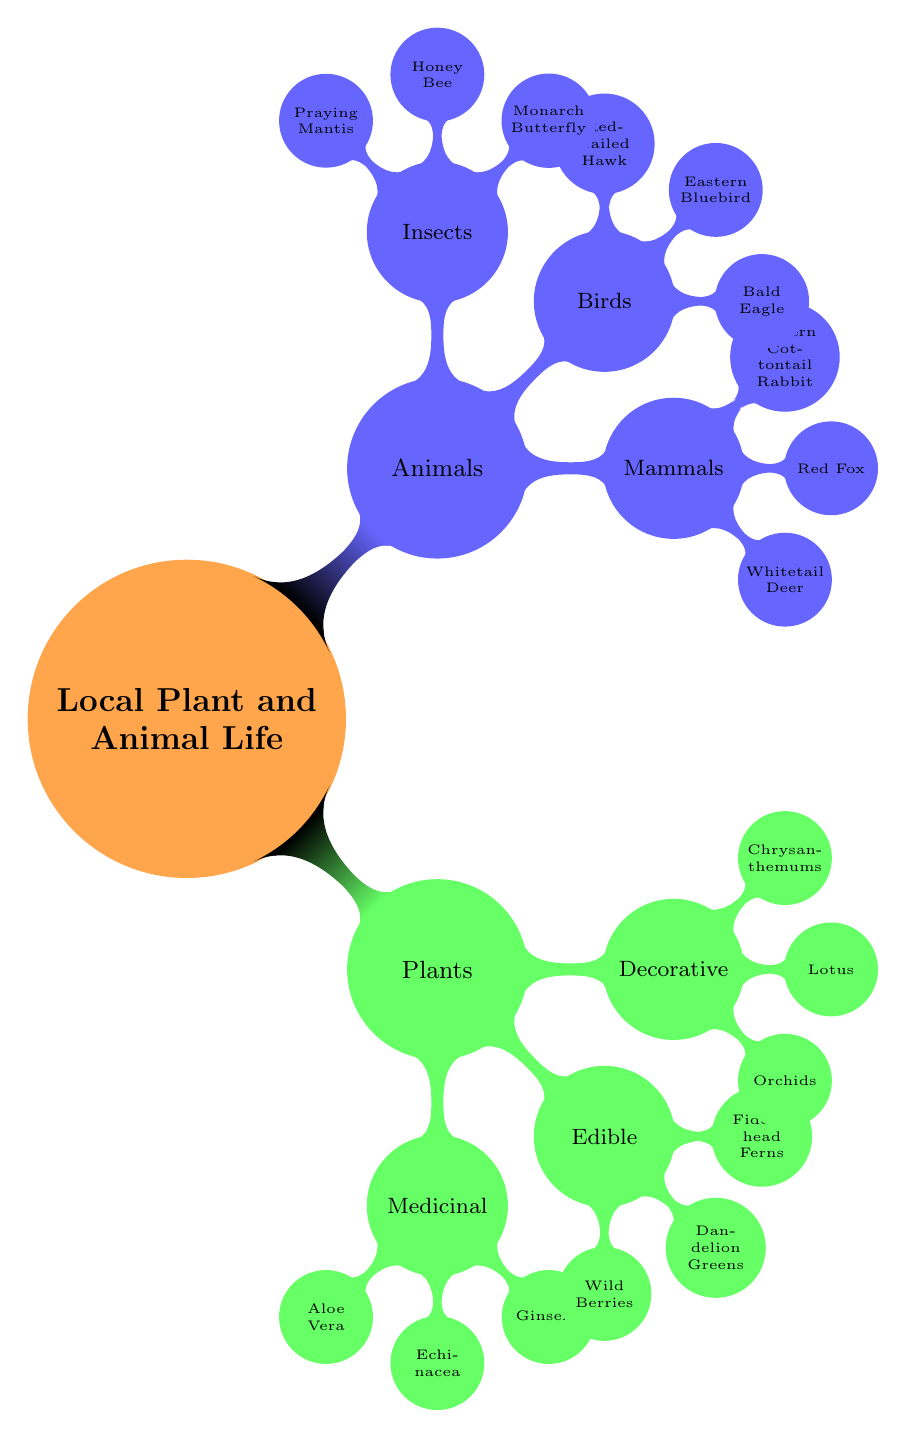What are the three categories of plants listed? The diagram shows that the plants are categorized into three groups: Medicinal, Edible, and Decorative.
Answer: Medicinal, Edible, Decorative How many types of mammals are mentioned? The diagram lists three mammals under the Animals category: Whitetail Deer, Red Fox, and Eastern Cottontail Rabbit. Therefore, the count is three.
Answer: 3 Which plant is categorized as both Edible and Medicinal? Looking at the plants, none from the list of Edible plants overlaps with those classified as Medicinal. The focus on distinct categories allows for this definitive answer.
Answer: None What type of animal is a Monarch Butterfly? A Monarch Butterfly falls under the category of Insects in the Animals section of the diagram.
Answer: Insect If there are 3 categories of plants and each has 3 examples listed, how many examples of plants are there in total? There are 3 categories (Medicinal, Edible, Decorative), and each includes 3 plants. Thus, the total number is calculated as 3 categories multiplied by 3 examples each, resulting in 9.
Answer: 9 Which bird has "Eagle" in its name? The diagram lists three birds, and the word "Eagle" appears only in the name of Bald Eagle, thus it is the answer.
Answer: Bald Eagle What are the three mammals mentioned? The diagram clearly lists three specific mammals: Whitetail Deer, Red Fox, and Eastern Cottontail Rabbit, which directly addresses the question.
Answer: Whitetail Deer, Red Fox, Eastern Cottontail Rabbit Which category does the Fiddlehead Fern belong to? The Fiddlehead Fern is included in the Edible category under Plants, signifying its classification.
Answer: Edible How many types of insects are listed? According to the diagram, there are three types of insects: Monarch Butterfly, Honey Bee, and Praying Mantis. Therefore, the total is three.
Answer: 3 